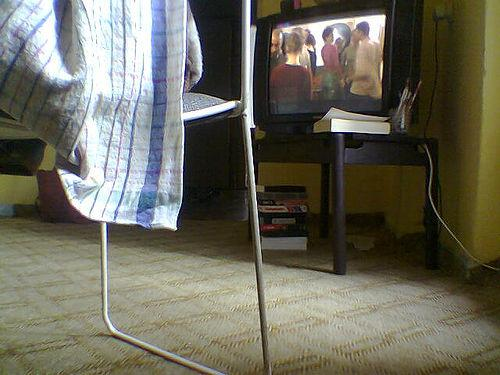Question: where was this picture taken?
Choices:
A. In the living room.
B. Backyard.
C. At a lake.
D. At a ski resort.
Answer with the letter. Answer: A Question: how is the television?
Choices:
A. Square.
B. It is doing well, thank you.
C. It is on.
D. It works.
Answer with the letter. Answer: C Question: who is on the television screen?
Choices:
A. Men and women.
B. Tennis players.
C. An avatar.
D. A cartoon character.
Answer with the letter. Answer: A Question: what color is the shirt?
Choices:
A. Blue and white.
B. Red.
C. Brown.
D. Yellow and black.
Answer with the letter. Answer: A 